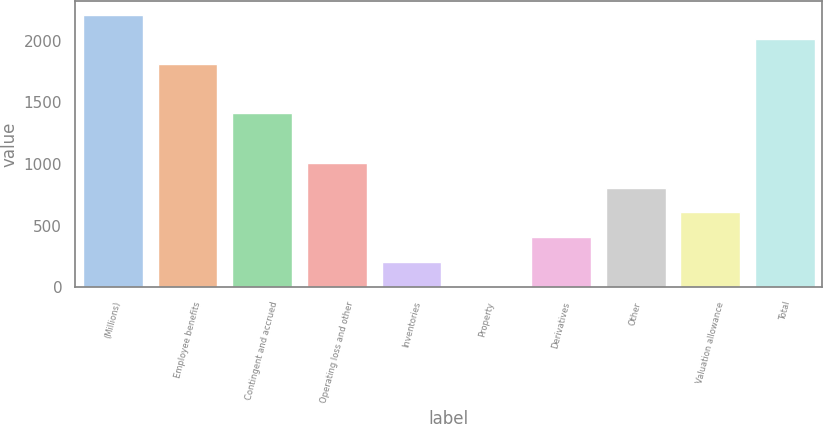Convert chart to OTSL. <chart><loc_0><loc_0><loc_500><loc_500><bar_chart><fcel>(Millions)<fcel>Employee benefits<fcel>Contingent and accrued<fcel>Operating loss and other<fcel>Inventories<fcel>Property<fcel>Derivatives<fcel>Other<fcel>Valuation allowance<fcel>Total<nl><fcel>2210.2<fcel>1809.8<fcel>1409.4<fcel>1009<fcel>208.2<fcel>8<fcel>408.4<fcel>808.8<fcel>608.6<fcel>2010<nl></chart> 